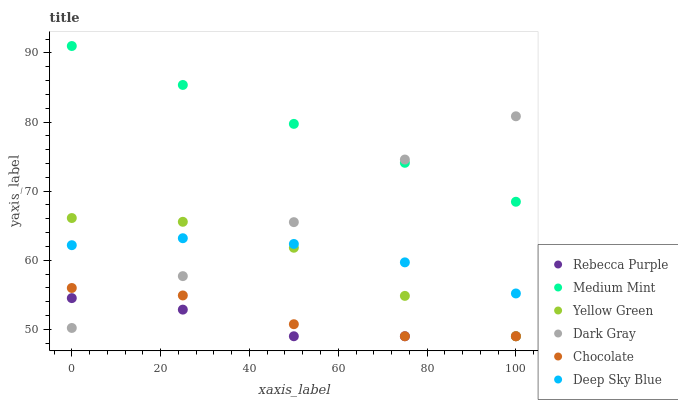Does Rebecca Purple have the minimum area under the curve?
Answer yes or no. Yes. Does Medium Mint have the maximum area under the curve?
Answer yes or no. Yes. Does Yellow Green have the minimum area under the curve?
Answer yes or no. No. Does Yellow Green have the maximum area under the curve?
Answer yes or no. No. Is Medium Mint the smoothest?
Answer yes or no. Yes. Is Yellow Green the roughest?
Answer yes or no. Yes. Is Chocolate the smoothest?
Answer yes or no. No. Is Chocolate the roughest?
Answer yes or no. No. Does Yellow Green have the lowest value?
Answer yes or no. Yes. Does Dark Gray have the lowest value?
Answer yes or no. No. Does Medium Mint have the highest value?
Answer yes or no. Yes. Does Yellow Green have the highest value?
Answer yes or no. No. Is Chocolate less than Deep Sky Blue?
Answer yes or no. Yes. Is Deep Sky Blue greater than Chocolate?
Answer yes or no. Yes. Does Medium Mint intersect Dark Gray?
Answer yes or no. Yes. Is Medium Mint less than Dark Gray?
Answer yes or no. No. Is Medium Mint greater than Dark Gray?
Answer yes or no. No. Does Chocolate intersect Deep Sky Blue?
Answer yes or no. No. 